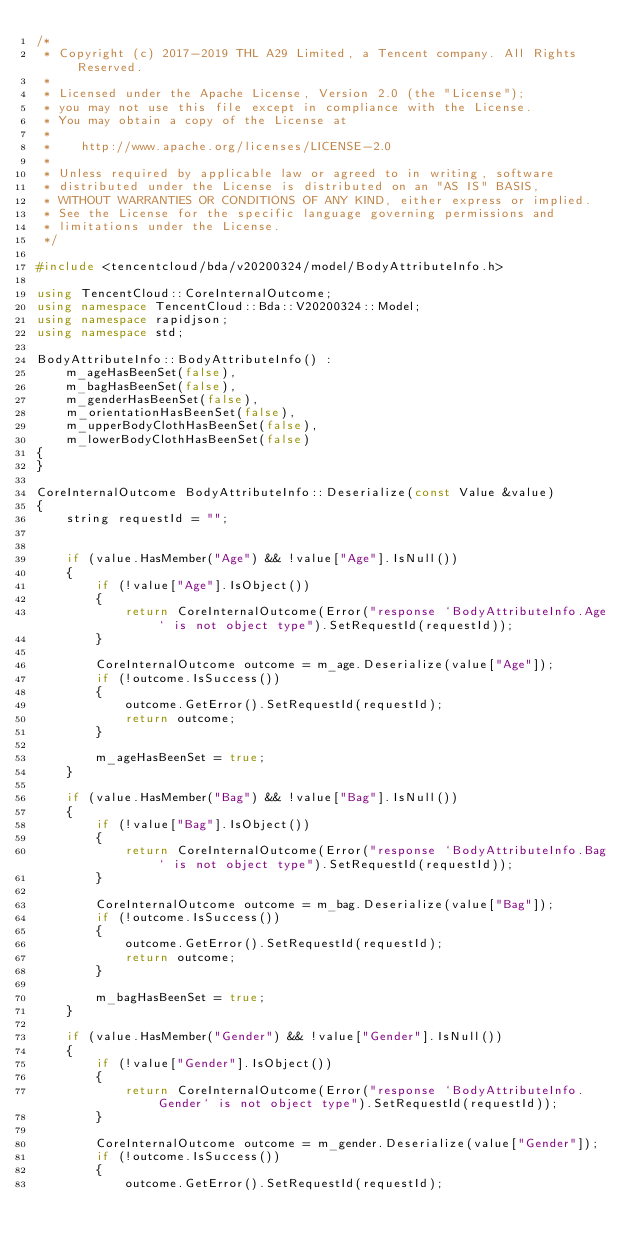Convert code to text. <code><loc_0><loc_0><loc_500><loc_500><_C++_>/*
 * Copyright (c) 2017-2019 THL A29 Limited, a Tencent company. All Rights Reserved.
 *
 * Licensed under the Apache License, Version 2.0 (the "License");
 * you may not use this file except in compliance with the License.
 * You may obtain a copy of the License at
 *
 *    http://www.apache.org/licenses/LICENSE-2.0
 *
 * Unless required by applicable law or agreed to in writing, software
 * distributed under the License is distributed on an "AS IS" BASIS,
 * WITHOUT WARRANTIES OR CONDITIONS OF ANY KIND, either express or implied.
 * See the License for the specific language governing permissions and
 * limitations under the License.
 */

#include <tencentcloud/bda/v20200324/model/BodyAttributeInfo.h>

using TencentCloud::CoreInternalOutcome;
using namespace TencentCloud::Bda::V20200324::Model;
using namespace rapidjson;
using namespace std;

BodyAttributeInfo::BodyAttributeInfo() :
    m_ageHasBeenSet(false),
    m_bagHasBeenSet(false),
    m_genderHasBeenSet(false),
    m_orientationHasBeenSet(false),
    m_upperBodyClothHasBeenSet(false),
    m_lowerBodyClothHasBeenSet(false)
{
}

CoreInternalOutcome BodyAttributeInfo::Deserialize(const Value &value)
{
    string requestId = "";


    if (value.HasMember("Age") && !value["Age"].IsNull())
    {
        if (!value["Age"].IsObject())
        {
            return CoreInternalOutcome(Error("response `BodyAttributeInfo.Age` is not object type").SetRequestId(requestId));
        }

        CoreInternalOutcome outcome = m_age.Deserialize(value["Age"]);
        if (!outcome.IsSuccess())
        {
            outcome.GetError().SetRequestId(requestId);
            return outcome;
        }

        m_ageHasBeenSet = true;
    }

    if (value.HasMember("Bag") && !value["Bag"].IsNull())
    {
        if (!value["Bag"].IsObject())
        {
            return CoreInternalOutcome(Error("response `BodyAttributeInfo.Bag` is not object type").SetRequestId(requestId));
        }

        CoreInternalOutcome outcome = m_bag.Deserialize(value["Bag"]);
        if (!outcome.IsSuccess())
        {
            outcome.GetError().SetRequestId(requestId);
            return outcome;
        }

        m_bagHasBeenSet = true;
    }

    if (value.HasMember("Gender") && !value["Gender"].IsNull())
    {
        if (!value["Gender"].IsObject())
        {
            return CoreInternalOutcome(Error("response `BodyAttributeInfo.Gender` is not object type").SetRequestId(requestId));
        }

        CoreInternalOutcome outcome = m_gender.Deserialize(value["Gender"]);
        if (!outcome.IsSuccess())
        {
            outcome.GetError().SetRequestId(requestId);</code> 